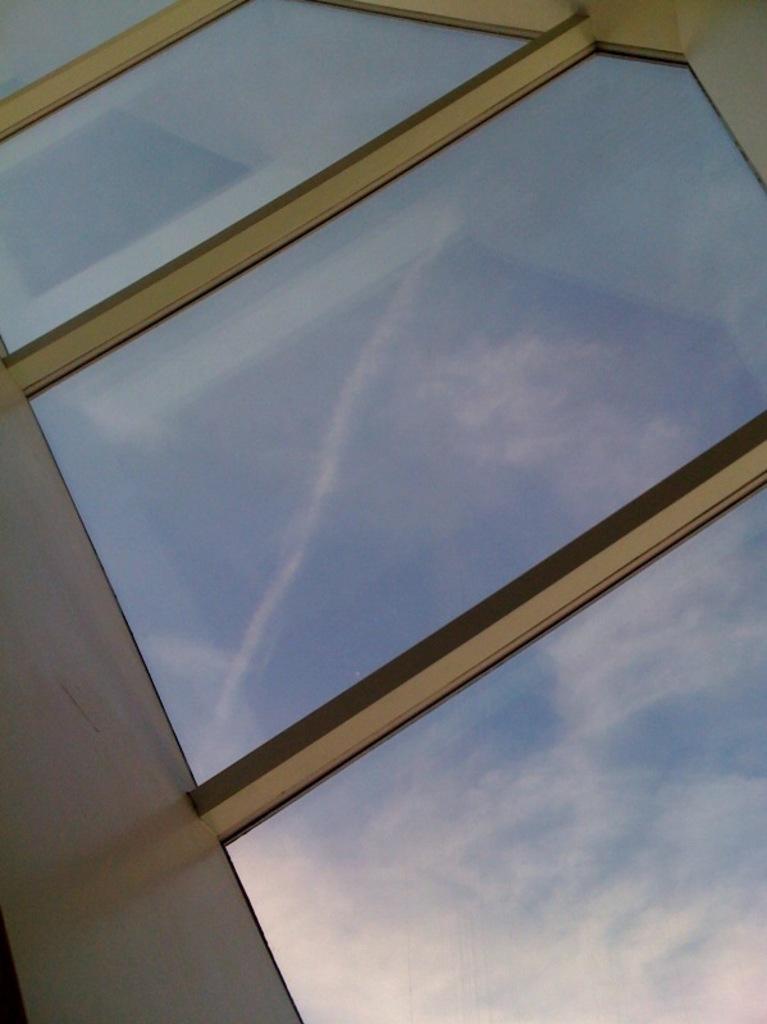How would you summarize this image in a sentence or two? In this picture we can see a few glass windows. Through these windows we can see sky. Sky is blue in color and cloudy. 